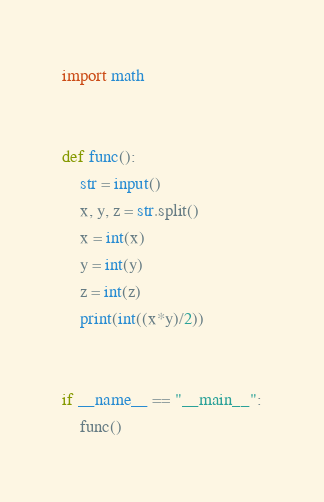<code> <loc_0><loc_0><loc_500><loc_500><_Python_>import math


def func():
    str = input()
    x, y, z = str.split()
    x = int(x)
    y = int(y)
    z = int(z)
    print(int((x*y)/2))


if __name__ == "__main__":
    func()
</code> 